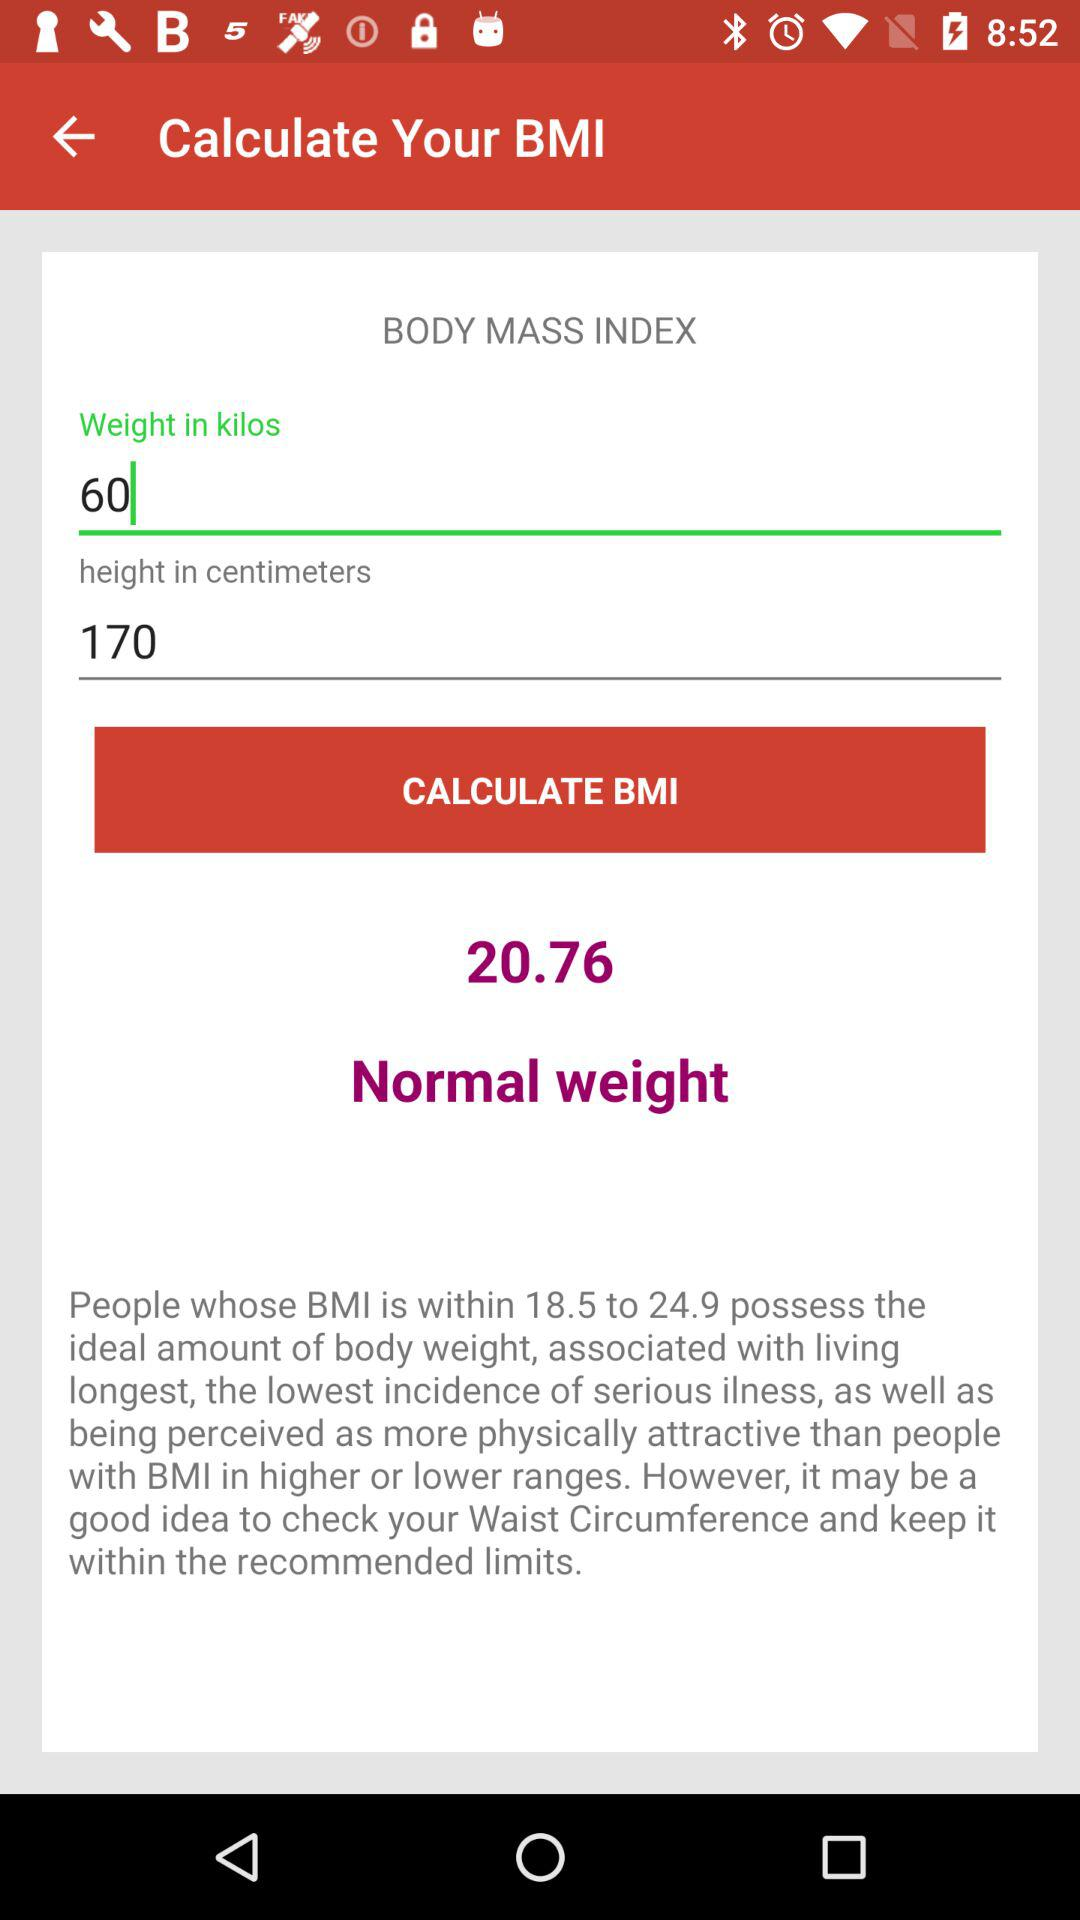What is the weight? The weight is 60 kilos. 